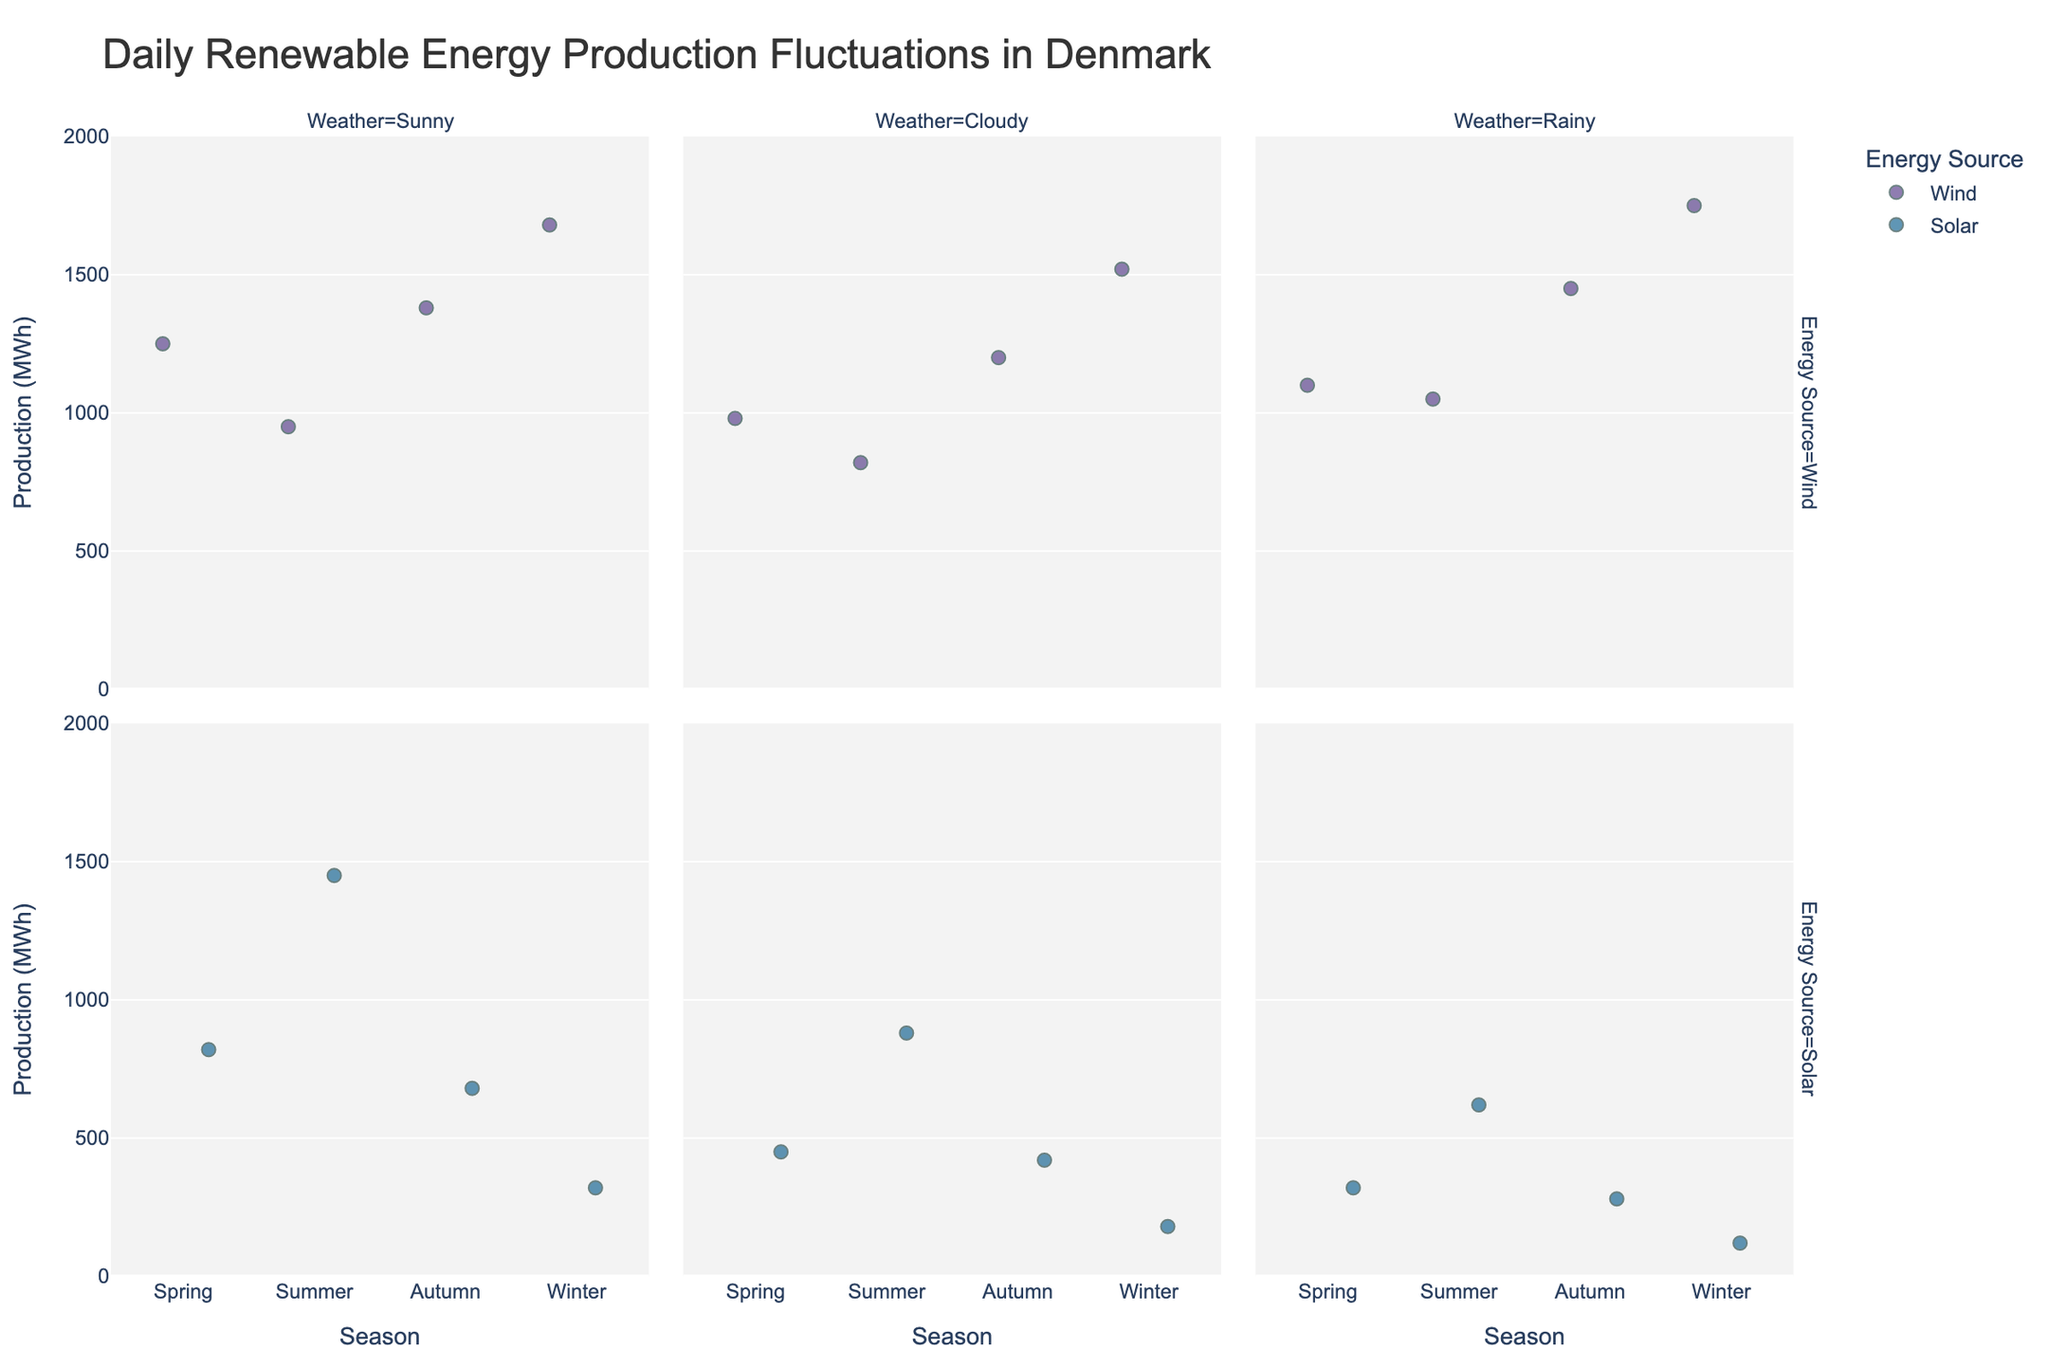What is the title of the strip plot? The title is usually displayed at the top of the figure. You can see it in the layout section of the figure.
Answer: Daily Renewable Energy Production Fluctuations in Denmark What are the seasons displayed in the x-axis? The x-axis categories represent the seasons, which can be observed under the "Season" label in the strips.
Answer: Spring, Summer, Autumn, Winter How does solar energy production in Summer during Sunny weather compare to Spring Sunny weather? Check the visual markers for solar energy under Sunny weather in both Summer and Spring. Compare the heights of these markers along the y-axis.
Answer: Higher in Summer Which energy source has the highest production MWh in Winter during Rainy weather? Look for the markers in Winter's Rainy weather facet row and identify which energy source marker is the highest along the y-axis.
Answer: Wind What is the range of production for wind energy during Autumn? Identify the markers for Wind energy in Autumn. The range is from the marker with the lowest to the highest y-value.
Answer: 1200 to 1450 MWh Which season shows the highest variability in solar energy production? Compare the spread of markers for solar energy in different seasons. Higher spread indicates higher variability.
Answer: Summer What color is used for solar energy markers in the chart? Examine the color legend to determine which color corresponds to solar energy markers.
Answer: Orange How does the energy production differ between Cloudy and Sunny weather in Spring for wind energy? Compare the y-axis values for wind energy in Spring under Cloudy and Sunny weather conditions.
Answer: Higher under Sunny What is the lowest solar energy production observed, and in which season and weather does it occur? Scan across the solar energy markers and identify the lowest marker, noting its season and weather facet.
Answer: 120 MWh in Winter, Rainy Is there more variability in wind production in Winter or Summer? Assess the spread of markers for wind production in Winter and Summer. A wider spread indicates more variability.
Answer: Winter 